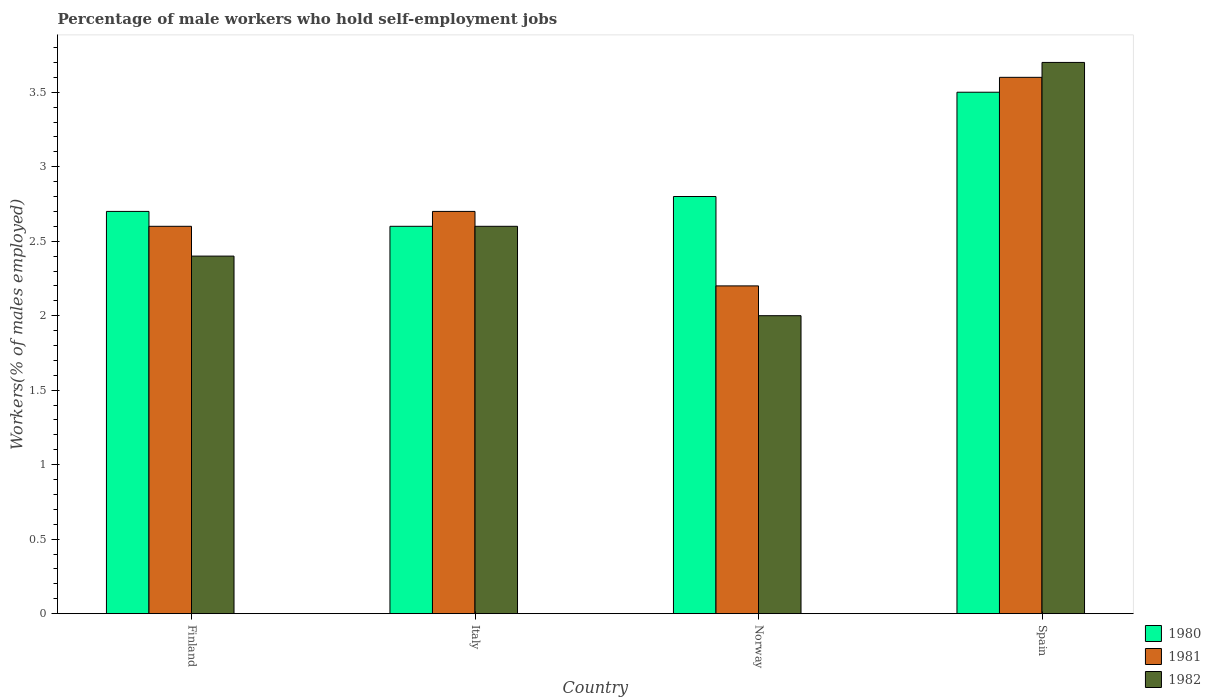How many different coloured bars are there?
Your answer should be compact. 3. Are the number of bars on each tick of the X-axis equal?
Keep it short and to the point. Yes. What is the percentage of self-employed male workers in 1982 in Finland?
Ensure brevity in your answer.  2.4. Across all countries, what is the maximum percentage of self-employed male workers in 1981?
Offer a very short reply. 3.6. Across all countries, what is the minimum percentage of self-employed male workers in 1981?
Give a very brief answer. 2.2. In which country was the percentage of self-employed male workers in 1982 maximum?
Your answer should be compact. Spain. What is the total percentage of self-employed male workers in 1982 in the graph?
Your answer should be very brief. 10.7. What is the difference between the percentage of self-employed male workers in 1980 in Finland and that in Norway?
Give a very brief answer. -0.1. What is the difference between the percentage of self-employed male workers in 1982 in Spain and the percentage of self-employed male workers in 1981 in Norway?
Give a very brief answer. 1.5. What is the average percentage of self-employed male workers in 1981 per country?
Ensure brevity in your answer.  2.77. What is the difference between the percentage of self-employed male workers of/in 1980 and percentage of self-employed male workers of/in 1982 in Norway?
Make the answer very short. 0.8. In how many countries, is the percentage of self-employed male workers in 1982 greater than 3.4 %?
Ensure brevity in your answer.  1. What is the ratio of the percentage of self-employed male workers in 1980 in Norway to that in Spain?
Your response must be concise. 0.8. What is the difference between the highest and the second highest percentage of self-employed male workers in 1981?
Offer a very short reply. -0.9. What is the difference between the highest and the lowest percentage of self-employed male workers in 1980?
Give a very brief answer. 0.9. In how many countries, is the percentage of self-employed male workers in 1981 greater than the average percentage of self-employed male workers in 1981 taken over all countries?
Offer a very short reply. 1. What does the 2nd bar from the right in Italy represents?
Provide a succinct answer. 1981. Is it the case that in every country, the sum of the percentage of self-employed male workers in 1981 and percentage of self-employed male workers in 1980 is greater than the percentage of self-employed male workers in 1982?
Make the answer very short. Yes. How many bars are there?
Make the answer very short. 12. What is the difference between two consecutive major ticks on the Y-axis?
Give a very brief answer. 0.5. Does the graph contain any zero values?
Your response must be concise. No. Does the graph contain grids?
Your answer should be very brief. No. How many legend labels are there?
Offer a very short reply. 3. What is the title of the graph?
Provide a short and direct response. Percentage of male workers who hold self-employment jobs. Does "2008" appear as one of the legend labels in the graph?
Offer a terse response. No. What is the label or title of the Y-axis?
Ensure brevity in your answer.  Workers(% of males employed). What is the Workers(% of males employed) in 1980 in Finland?
Keep it short and to the point. 2.7. What is the Workers(% of males employed) of 1981 in Finland?
Provide a short and direct response. 2.6. What is the Workers(% of males employed) in 1982 in Finland?
Give a very brief answer. 2.4. What is the Workers(% of males employed) in 1980 in Italy?
Keep it short and to the point. 2.6. What is the Workers(% of males employed) of 1981 in Italy?
Ensure brevity in your answer.  2.7. What is the Workers(% of males employed) of 1982 in Italy?
Your answer should be compact. 2.6. What is the Workers(% of males employed) in 1980 in Norway?
Provide a short and direct response. 2.8. What is the Workers(% of males employed) of 1981 in Norway?
Your answer should be compact. 2.2. What is the Workers(% of males employed) in 1982 in Norway?
Make the answer very short. 2. What is the Workers(% of males employed) of 1981 in Spain?
Ensure brevity in your answer.  3.6. What is the Workers(% of males employed) in 1982 in Spain?
Provide a succinct answer. 3.7. Across all countries, what is the maximum Workers(% of males employed) in 1981?
Your answer should be very brief. 3.6. Across all countries, what is the maximum Workers(% of males employed) of 1982?
Your answer should be compact. 3.7. Across all countries, what is the minimum Workers(% of males employed) of 1980?
Your response must be concise. 2.6. Across all countries, what is the minimum Workers(% of males employed) in 1981?
Offer a very short reply. 2.2. Across all countries, what is the minimum Workers(% of males employed) of 1982?
Your answer should be compact. 2. What is the total Workers(% of males employed) of 1980 in the graph?
Your response must be concise. 11.6. What is the total Workers(% of males employed) of 1982 in the graph?
Your response must be concise. 10.7. What is the difference between the Workers(% of males employed) in 1980 in Finland and that in Italy?
Your response must be concise. 0.1. What is the difference between the Workers(% of males employed) of 1982 in Finland and that in Italy?
Provide a succinct answer. -0.2. What is the difference between the Workers(% of males employed) of 1980 in Finland and that in Spain?
Offer a terse response. -0.8. What is the difference between the Workers(% of males employed) in 1981 in Finland and that in Spain?
Make the answer very short. -1. What is the difference between the Workers(% of males employed) of 1980 in Italy and that in Norway?
Provide a succinct answer. -0.2. What is the difference between the Workers(% of males employed) of 1981 in Italy and that in Norway?
Your answer should be compact. 0.5. What is the difference between the Workers(% of males employed) in 1980 in Italy and that in Spain?
Provide a succinct answer. -0.9. What is the difference between the Workers(% of males employed) in 1981 in Italy and that in Spain?
Your answer should be compact. -0.9. What is the difference between the Workers(% of males employed) in 1981 in Norway and that in Spain?
Keep it short and to the point. -1.4. What is the difference between the Workers(% of males employed) of 1980 in Finland and the Workers(% of males employed) of 1981 in Italy?
Offer a terse response. 0. What is the difference between the Workers(% of males employed) of 1980 in Finland and the Workers(% of males employed) of 1982 in Italy?
Offer a terse response. 0.1. What is the difference between the Workers(% of males employed) of 1981 in Finland and the Workers(% of males employed) of 1982 in Italy?
Provide a short and direct response. 0. What is the difference between the Workers(% of males employed) of 1980 in Finland and the Workers(% of males employed) of 1981 in Norway?
Offer a terse response. 0.5. What is the difference between the Workers(% of males employed) of 1981 in Finland and the Workers(% of males employed) of 1982 in Norway?
Offer a very short reply. 0.6. What is the difference between the Workers(% of males employed) of 1980 in Finland and the Workers(% of males employed) of 1981 in Spain?
Provide a succinct answer. -0.9. What is the difference between the Workers(% of males employed) in 1980 in Italy and the Workers(% of males employed) in 1981 in Norway?
Your answer should be compact. 0.4. What is the difference between the Workers(% of males employed) of 1980 in Italy and the Workers(% of males employed) of 1982 in Norway?
Your answer should be compact. 0.6. What is the difference between the Workers(% of males employed) in 1981 in Italy and the Workers(% of males employed) in 1982 in Norway?
Offer a very short reply. 0.7. What is the difference between the Workers(% of males employed) in 1980 in Italy and the Workers(% of males employed) in 1981 in Spain?
Ensure brevity in your answer.  -1. What is the average Workers(% of males employed) in 1980 per country?
Make the answer very short. 2.9. What is the average Workers(% of males employed) of 1981 per country?
Your answer should be very brief. 2.77. What is the average Workers(% of males employed) of 1982 per country?
Give a very brief answer. 2.67. What is the difference between the Workers(% of males employed) of 1980 and Workers(% of males employed) of 1982 in Finland?
Keep it short and to the point. 0.3. What is the difference between the Workers(% of males employed) of 1980 and Workers(% of males employed) of 1981 in Italy?
Make the answer very short. -0.1. What is the difference between the Workers(% of males employed) of 1980 and Workers(% of males employed) of 1982 in Italy?
Your answer should be very brief. 0. What is the difference between the Workers(% of males employed) of 1981 and Workers(% of males employed) of 1982 in Italy?
Offer a terse response. 0.1. What is the difference between the Workers(% of males employed) of 1980 and Workers(% of males employed) of 1982 in Norway?
Ensure brevity in your answer.  0.8. What is the difference between the Workers(% of males employed) of 1980 and Workers(% of males employed) of 1981 in Spain?
Give a very brief answer. -0.1. What is the ratio of the Workers(% of males employed) in 1980 in Finland to that in Italy?
Your answer should be compact. 1.04. What is the ratio of the Workers(% of males employed) of 1982 in Finland to that in Italy?
Keep it short and to the point. 0.92. What is the ratio of the Workers(% of males employed) in 1981 in Finland to that in Norway?
Give a very brief answer. 1.18. What is the ratio of the Workers(% of males employed) in 1980 in Finland to that in Spain?
Make the answer very short. 0.77. What is the ratio of the Workers(% of males employed) in 1981 in Finland to that in Spain?
Provide a short and direct response. 0.72. What is the ratio of the Workers(% of males employed) of 1982 in Finland to that in Spain?
Make the answer very short. 0.65. What is the ratio of the Workers(% of males employed) of 1980 in Italy to that in Norway?
Offer a very short reply. 0.93. What is the ratio of the Workers(% of males employed) in 1981 in Italy to that in Norway?
Your answer should be very brief. 1.23. What is the ratio of the Workers(% of males employed) in 1980 in Italy to that in Spain?
Offer a very short reply. 0.74. What is the ratio of the Workers(% of males employed) of 1981 in Italy to that in Spain?
Give a very brief answer. 0.75. What is the ratio of the Workers(% of males employed) in 1982 in Italy to that in Spain?
Make the answer very short. 0.7. What is the ratio of the Workers(% of males employed) of 1980 in Norway to that in Spain?
Your answer should be very brief. 0.8. What is the ratio of the Workers(% of males employed) in 1981 in Norway to that in Spain?
Provide a succinct answer. 0.61. What is the ratio of the Workers(% of males employed) in 1982 in Norway to that in Spain?
Offer a terse response. 0.54. What is the difference between the highest and the second highest Workers(% of males employed) of 1980?
Your response must be concise. 0.7. What is the difference between the highest and the second highest Workers(% of males employed) of 1981?
Provide a short and direct response. 0.9. What is the difference between the highest and the second highest Workers(% of males employed) in 1982?
Ensure brevity in your answer.  1.1. What is the difference between the highest and the lowest Workers(% of males employed) in 1980?
Your answer should be compact. 0.9. 